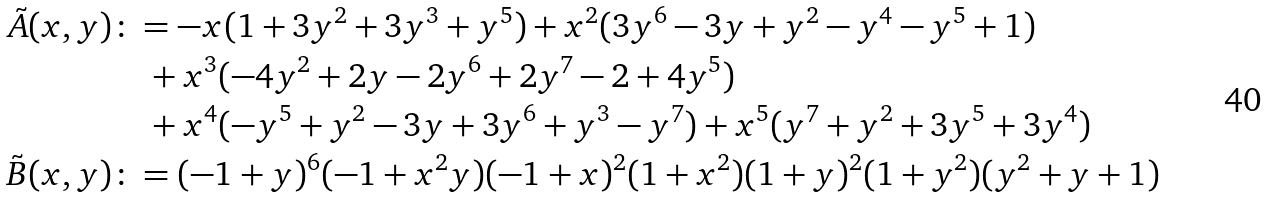Convert formula to latex. <formula><loc_0><loc_0><loc_500><loc_500>\tilde { A } ( x , y ) & \colon = - x ( 1 + 3 y ^ { 2 } + 3 y ^ { 3 } + y ^ { 5 } ) + x ^ { 2 } ( 3 y ^ { 6 } - 3 y + y ^ { 2 } - y ^ { 4 } - y ^ { 5 } + 1 ) \\ & \quad + x ^ { 3 } ( - 4 y ^ { 2 } + 2 y - 2 y ^ { 6 } + 2 y ^ { 7 } - 2 + 4 y ^ { 5 } ) \\ & \quad + x ^ { 4 } ( - y ^ { 5 } + y ^ { 2 } - 3 y + 3 y ^ { 6 } + y ^ { 3 } - y ^ { 7 } ) + x ^ { 5 } ( y ^ { 7 } + y ^ { 2 } + 3 y ^ { 5 } + 3 y ^ { 4 } ) \\ \tilde { B } ( x , y ) & \colon = ( - 1 + y ) ^ { 6 } ( - 1 + x ^ { 2 } y ) ( - 1 + x ) ^ { 2 } ( 1 + x ^ { 2 } ) ( 1 + y ) ^ { 2 } ( 1 + y ^ { 2 } ) ( y ^ { 2 } + y + 1 )</formula> 